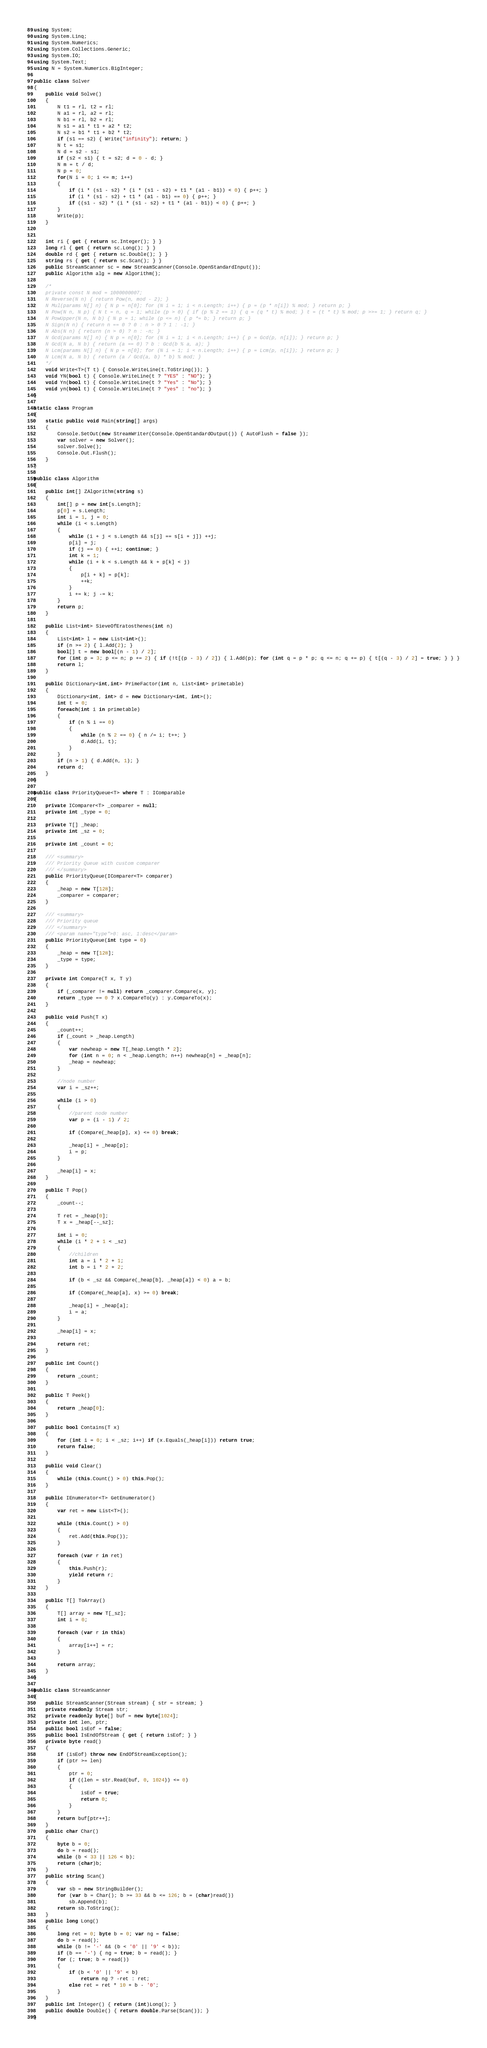<code> <loc_0><loc_0><loc_500><loc_500><_C#_>using System;
using System.Linq;
using System.Numerics;
using System.Collections.Generic;
using System.IO;
using System.Text;
using N = System.Numerics.BigInteger;

public class Solver
{
    public void Solve()
    {
        N t1 = rl, t2 = rl;
        N a1 = rl, a2 = rl;
        N b1 = rl, b2 = rl;
        N s1 = a1 * t1 + a2 * t2;
        N s2 = b1 * t1 + b2 * t2;
        if (s1 == s2) { Write("infinity"); return; }
        N t = s1;
        N d = s2 - s1;
        if (s2 < s1) { t = s2; d = 0 - d; }
        N m = t / d;
        N p = 0;
        for(N i = 0; i <= m; i++)
        {
            if (i * (s1 - s2) * (i * (s1 - s2) + t1 * (a1 - b1)) < 0) { p++; }
            if (i * (s1 - s2) + t1 * (a1 - b1) == 0) { p++; }
            if ((s1 - s2) * (i * (s1 - s2) + t1 * (a1 - b1)) < 0) { p++; }
        }
        Write(p);
    }
    

    int ri { get { return sc.Integer(); } }
    long rl { get { return sc.Long(); } }
    double rd { get { return sc.Double(); } }
    string rs { get { return sc.Scan(); } }
    public StreamScanner sc = new StreamScanner(Console.OpenStandardInput());
    public Algorithm alg = new Algorithm();

    /*
    private const N mod = 1000000007;
    N Reverse(N n) { return Pow(n, mod - 2); }
    N Mul(params N[] n) { N p = n[0]; for (N i = 1; i < n.Length; i++) { p = (p * n[i]) % mod; } return p; }
    N Pow(N n, N p) { N t = n, q = 1; while (p > 0) { if (p % 2 == 1) { q = (q * t) % mod; } t = (t * t) % mod; p >>= 1; } return q; }
    N PowUpper(N n, N b) { N p = 1; while (p <= n) { p *= b; } return p; }
    N Sign(N n) { return n == 0 ? 0 : n > 0 ? 1 : -1; }
    N Abs(N n) { return (n > 0) ? n : -n; }
    N Gcd(params N[] n) { N p = n[0]; for (N i = 1; i < n.Length; i++) { p = Gcd(p, n[i]); } return p; }
    N Gcd(N a, N b) { return (a == 0) ? b : Gcd(b % a, a); }
    N Lcm(params N[] n) { N p = n[0]; for (N i = 1; i < n.Length; i++) { p = Lcm(p, n[i]); } return p; }
    N Lcm(N a, N b) { return (a / Gcd(a, b) * b) % mod; }
    */
    void Write<T>(T t) { Console.WriteLine(t.ToString()); }
    void YN(bool t) { Console.WriteLine(t ? "YES" : "NO"); }
    void Yn(bool t) { Console.WriteLine(t ? "Yes" : "No"); }
    void yn(bool t) { Console.WriteLine(t ? "yes" : "no"); }
}

static class Program
{
    static public void Main(string[] args)
    {
        Console.SetOut(new StreamWriter(Console.OpenStandardOutput()) { AutoFlush = false });
        var solver = new Solver();
        solver.Solve();
        Console.Out.Flush();
    }
}

public class Algorithm
{
    public int[] ZAlgorithm(string s)
    {
        int[] p = new int[s.Length];
        p[0] = s.Length;
        int i = 1, j = 0;
        while (i < s.Length)
        {
            while (i + j < s.Length && s[j] == s[i + j]) ++j;
            p[i] = j;
            if (j == 0) { ++i; continue; }
            int k = 1;
            while (i + k < s.Length && k + p[k] < j)
            {
                p[i + k] = p[k];
                ++k;
            }
            i += k; j -= k;
        }
        return p;
    }

    public List<int> SieveOfEratosthenes(int n)
    {
        List<int> l = new List<int>();
        if (n >= 2) { l.Add(2); }
        bool[] t = new bool[(n - 1) / 2];
        for (int p = 3; p <= n; p += 2) { if (!t[(p - 3) / 2]) { l.Add(p); for (int q = p * p; q <= n; q += p) { t[(q - 3) / 2] = true; } } }
        return l;
    }

    public Dictionary<int,int> PrimeFactor(int n, List<int> primetable)
    {
        Dictionary<int, int> d = new Dictionary<int, int>();
        int t = 0;
        foreach(int i in primetable)
        {
            if (n % i == 0)
            {
                while (n % 2 == 0) { n /= i; t++; }
                d.Add(i, t);
            }
        }
        if (n > 1) { d.Add(n, 1); }
        return d;
    }
}

public class PriorityQueue<T> where T : IComparable
{
    private IComparer<T> _comparer = null;
    private int _type = 0;

    private T[] _heap;
    private int _sz = 0;

    private int _count = 0;

    /// <summary>
    /// Priority Queue with custom comparer
    /// </summary>
    public PriorityQueue(IComparer<T> comparer)
    {
        _heap = new T[128];
        _comparer = comparer;
    }

    /// <summary>
    /// Priority queue
    /// </summary>
    /// <param name="type">0: asc, 1:desc</param>
    public PriorityQueue(int type = 0)
    {
        _heap = new T[128];
        _type = type;
    }

    private int Compare(T x, T y)
    {
        if (_comparer != null) return _comparer.Compare(x, y);
        return _type == 0 ? x.CompareTo(y) : y.CompareTo(x);
    }

    public void Push(T x)
    {
        _count++;
        if (_count > _heap.Length)
        {
            var newheap = new T[_heap.Length * 2];
            for (int n = 0; n < _heap.Length; n++) newheap[n] = _heap[n];
            _heap = newheap;
        }

        //node number
        var i = _sz++;

        while (i > 0)
        {
            //parent node number
            var p = (i - 1) / 2;

            if (Compare(_heap[p], x) <= 0) break;

            _heap[i] = _heap[p];
            i = p;
        }

        _heap[i] = x;
    }

    public T Pop()
    {
        _count--;

        T ret = _heap[0];
        T x = _heap[--_sz];

        int i = 0;
        while (i * 2 + 1 < _sz)
        {
            //children
            int a = i * 2 + 1;
            int b = i * 2 + 2;

            if (b < _sz && Compare(_heap[b], _heap[a]) < 0) a = b;

            if (Compare(_heap[a], x) >= 0) break;

            _heap[i] = _heap[a];
            i = a;
        }

        _heap[i] = x;

        return ret;
    }

    public int Count()
    {
        return _count;
    }

    public T Peek()
    {
        return _heap[0];
    }

    public bool Contains(T x)
    {
        for (int i = 0; i < _sz; i++) if (x.Equals(_heap[i])) return true;
        return false;
    }

    public void Clear()
    {
        while (this.Count() > 0) this.Pop();
    }

    public IEnumerator<T> GetEnumerator()
    {
        var ret = new List<T>();

        while (this.Count() > 0)
        {
            ret.Add(this.Pop());
        }

        foreach (var r in ret)
        {
            this.Push(r);
            yield return r;
        }
    }

    public T[] ToArray()
    {
        T[] array = new T[_sz];
        int i = 0;

        foreach (var r in this)
        {
            array[i++] = r;
        }

        return array;
    }
}

public class StreamScanner
{
    public StreamScanner(Stream stream) { str = stream; }
    private readonly Stream str;
    private readonly byte[] buf = new byte[1024];
    private int len, ptr;
    public bool isEof = false;
    public bool IsEndOfStream { get { return isEof; } }
    private byte read()
    {
        if (isEof) throw new EndOfStreamException();
        if (ptr >= len)
        {
            ptr = 0;
            if ((len = str.Read(buf, 0, 1024)) <= 0)
            {
                isEof = true;
                return 0;
            }
        }
        return buf[ptr++];
    }
    public char Char()
    {
        byte b = 0;
        do b = read();
        while (b < 33 || 126 < b);
        return (char)b;
    }
    public string Scan()
    {
        var sb = new StringBuilder();
        for (var b = Char(); b >= 33 && b <= 126; b = (char)read())
            sb.Append(b);
        return sb.ToString();
    }
    public long Long()
    {
        long ret = 0; byte b = 0; var ng = false;
        do b = read();
        while (b != '-' && (b < '0' || '9' < b));
        if (b == '-') { ng = true; b = read(); }
        for (; true; b = read())
        {
            if (b < '0' || '9' < b)
                return ng ? -ret : ret;
            else ret = ret * 10 + b - '0';
        }
    }
    public int Integer() { return (int)Long(); }
    public double Double() { return double.Parse(Scan()); }
}
</code> 